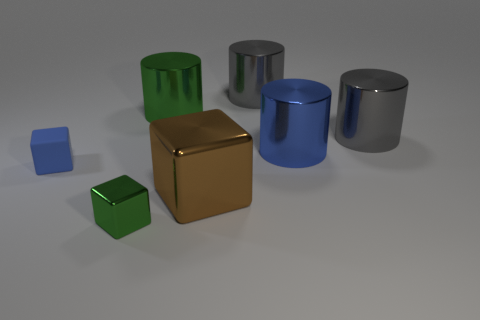What number of objects are small gray metal things or big green objects?
Provide a short and direct response. 1. How many green objects are the same material as the big cube?
Make the answer very short. 2. What size is the green thing that is the same shape as the big blue object?
Make the answer very short. Large. There is a large blue metallic object; are there any metallic cylinders to the left of it?
Your response must be concise. Yes. What is the big blue object made of?
Provide a short and direct response. Metal. There is a metallic block to the left of the big green metal object; is it the same color as the big cube?
Offer a terse response. No. Is there anything else that has the same shape as the brown thing?
Make the answer very short. Yes. There is a tiny metal thing that is the same shape as the large brown shiny object; what is its color?
Your response must be concise. Green. There is a blue object left of the large blue thing; what is it made of?
Offer a very short reply. Rubber. What color is the tiny metallic cube?
Your response must be concise. Green. 